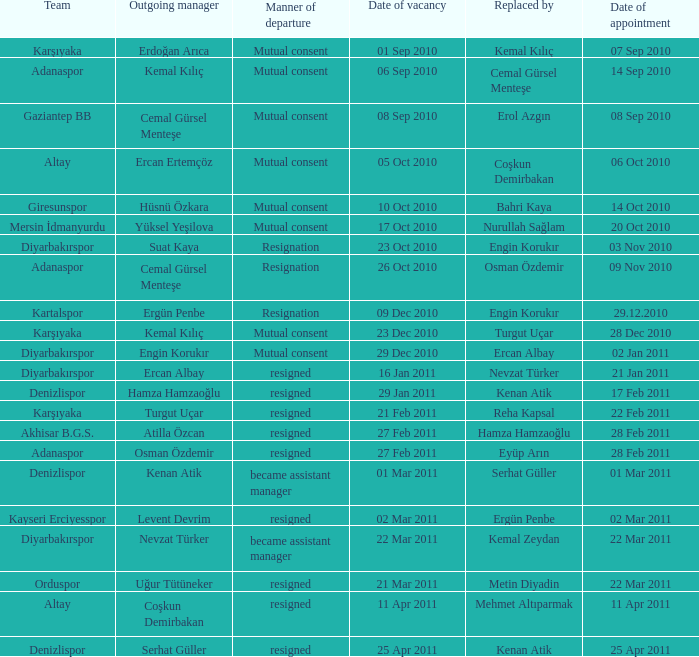On which date did the manager role at kartalspor become available? 09 Dec 2010. Can you give me this table as a dict? {'header': ['Team', 'Outgoing manager', 'Manner of departure', 'Date of vacancy', 'Replaced by', 'Date of appointment'], 'rows': [['Karşıyaka', 'Erdoğan Arıca', 'Mutual consent', '01 Sep 2010', 'Kemal Kılıç', '07 Sep 2010'], ['Adanaspor', 'Kemal Kılıç', 'Mutual consent', '06 Sep 2010', 'Cemal Gürsel Menteşe', '14 Sep 2010'], ['Gaziantep BB', 'Cemal Gürsel Menteşe', 'Mutual consent', '08 Sep 2010', 'Erol Azgın', '08 Sep 2010'], ['Altay', 'Ercan Ertemçöz', 'Mutual consent', '05 Oct 2010', 'Coşkun Demirbakan', '06 Oct 2010'], ['Giresunspor', 'Hüsnü Özkara', 'Mutual consent', '10 Oct 2010', 'Bahri Kaya', '14 Oct 2010'], ['Mersin İdmanyurdu', 'Yüksel Yeşilova', 'Mutual consent', '17 Oct 2010', 'Nurullah Sağlam', '20 Oct 2010'], ['Diyarbakırspor', 'Suat Kaya', 'Resignation', '23 Oct 2010', 'Engin Korukır', '03 Nov 2010'], ['Adanaspor', 'Cemal Gürsel Menteşe', 'Resignation', '26 Oct 2010', 'Osman Özdemir', '09 Nov 2010'], ['Kartalspor', 'Ergün Penbe', 'Resignation', '09 Dec 2010', 'Engin Korukır', '29.12.2010'], ['Karşıyaka', 'Kemal Kılıç', 'Mutual consent', '23 Dec 2010', 'Turgut Uçar', '28 Dec 2010'], ['Diyarbakırspor', 'Engin Korukır', 'Mutual consent', '29 Dec 2010', 'Ercan Albay', '02 Jan 2011'], ['Diyarbakırspor', 'Ercan Albay', 'resigned', '16 Jan 2011', 'Nevzat Türker', '21 Jan 2011'], ['Denizlispor', 'Hamza Hamzaoğlu', 'resigned', '29 Jan 2011', 'Kenan Atik', '17 Feb 2011'], ['Karşıyaka', 'Turgut Uçar', 'resigned', '21 Feb 2011', 'Reha Kapsal', '22 Feb 2011'], ['Akhisar B.G.S.', 'Atilla Özcan', 'resigned', '27 Feb 2011', 'Hamza Hamzaoğlu', '28 Feb 2011'], ['Adanaspor', 'Osman Özdemir', 'resigned', '27 Feb 2011', 'Eyüp Arın', '28 Feb 2011'], ['Denizlispor', 'Kenan Atik', 'became assistant manager', '01 Mar 2011', 'Serhat Güller', '01 Mar 2011'], ['Kayseri Erciyesspor', 'Levent Devrim', 'resigned', '02 Mar 2011', 'Ergün Penbe', '02 Mar 2011'], ['Diyarbakırspor', 'Nevzat Türker', 'became assistant manager', '22 Mar 2011', 'Kemal Zeydan', '22 Mar 2011'], ['Orduspor', 'Uğur Tütüneker', 'resigned', '21 Mar 2011', 'Metin Diyadin', '22 Mar 2011'], ['Altay', 'Coşkun Demirbakan', 'resigned', '11 Apr 2011', 'Mehmet Altıparmak', '11 Apr 2011'], ['Denizlispor', 'Serhat Güller', 'resigned', '25 Apr 2011', 'Kenan Atik', '25 Apr 2011']]} 